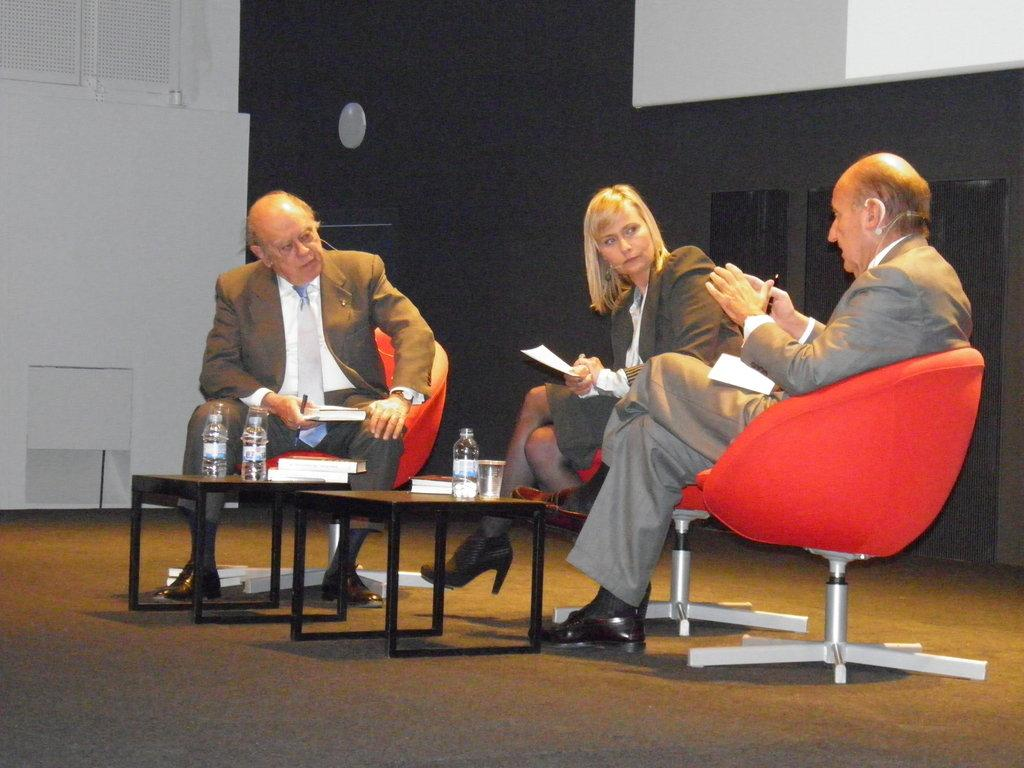What is the person at the right side of the image doing? The person at the right side is talking. How many other people are present in the image? There are two other persons sitting and listening. What objects can be seen on the table in the image? There are bottles, glasses, and books on the table. What type of camera is being used by the person at the right side of the image? There is no camera present in the image; the person is talking. How much powder is on the table in the image? There is no mention of powder in the image; it only includes bottles, glasses, and books on the table. 